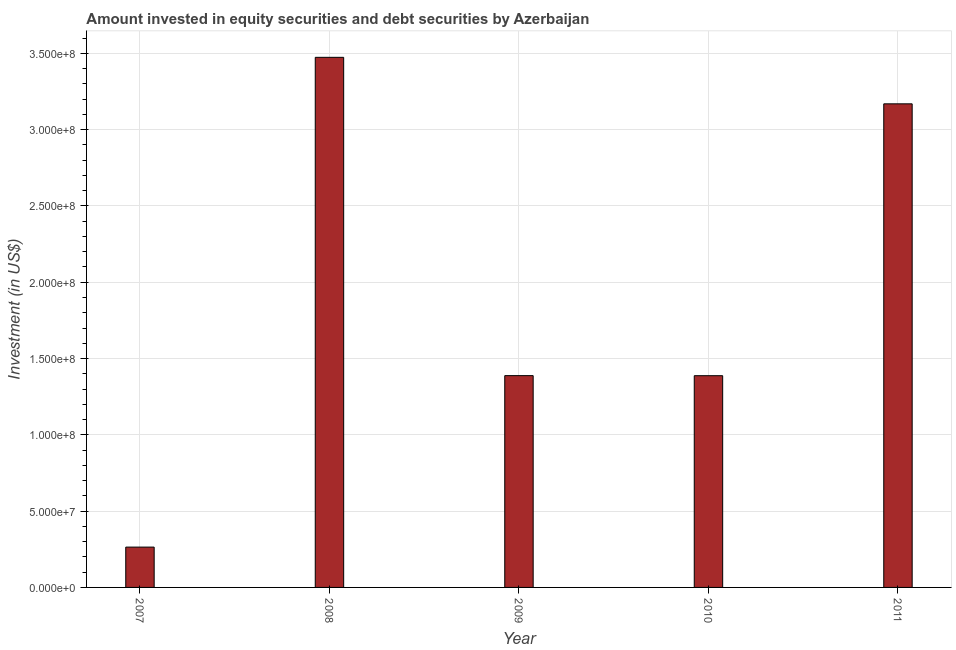What is the title of the graph?
Keep it short and to the point. Amount invested in equity securities and debt securities by Azerbaijan. What is the label or title of the X-axis?
Your answer should be very brief. Year. What is the label or title of the Y-axis?
Provide a short and direct response. Investment (in US$). What is the portfolio investment in 2008?
Offer a terse response. 3.47e+08. Across all years, what is the maximum portfolio investment?
Make the answer very short. 3.47e+08. Across all years, what is the minimum portfolio investment?
Offer a very short reply. 2.64e+07. In which year was the portfolio investment maximum?
Offer a very short reply. 2008. What is the sum of the portfolio investment?
Offer a terse response. 9.68e+08. What is the difference between the portfolio investment in 2009 and 2011?
Offer a very short reply. -1.78e+08. What is the average portfolio investment per year?
Offer a very short reply. 1.94e+08. What is the median portfolio investment?
Give a very brief answer. 1.39e+08. Do a majority of the years between 2010 and 2007 (inclusive) have portfolio investment greater than 320000000 US$?
Provide a short and direct response. Yes. What is the ratio of the portfolio investment in 2008 to that in 2010?
Give a very brief answer. 2.5. Is the difference between the portfolio investment in 2007 and 2008 greater than the difference between any two years?
Offer a terse response. Yes. What is the difference between the highest and the second highest portfolio investment?
Keep it short and to the point. 3.05e+07. Is the sum of the portfolio investment in 2007 and 2008 greater than the maximum portfolio investment across all years?
Offer a terse response. Yes. What is the difference between the highest and the lowest portfolio investment?
Your response must be concise. 3.21e+08. Are all the bars in the graph horizontal?
Your answer should be compact. No. How many years are there in the graph?
Provide a succinct answer. 5. What is the difference between two consecutive major ticks on the Y-axis?
Your answer should be compact. 5.00e+07. Are the values on the major ticks of Y-axis written in scientific E-notation?
Make the answer very short. Yes. What is the Investment (in US$) of 2007?
Ensure brevity in your answer.  2.64e+07. What is the Investment (in US$) in 2008?
Give a very brief answer. 3.47e+08. What is the Investment (in US$) of 2009?
Make the answer very short. 1.39e+08. What is the Investment (in US$) in 2010?
Your answer should be very brief. 1.39e+08. What is the Investment (in US$) of 2011?
Make the answer very short. 3.17e+08. What is the difference between the Investment (in US$) in 2007 and 2008?
Your answer should be compact. -3.21e+08. What is the difference between the Investment (in US$) in 2007 and 2009?
Your answer should be compact. -1.12e+08. What is the difference between the Investment (in US$) in 2007 and 2010?
Give a very brief answer. -1.12e+08. What is the difference between the Investment (in US$) in 2007 and 2011?
Provide a short and direct response. -2.90e+08. What is the difference between the Investment (in US$) in 2008 and 2009?
Provide a short and direct response. 2.09e+08. What is the difference between the Investment (in US$) in 2008 and 2010?
Give a very brief answer. 2.09e+08. What is the difference between the Investment (in US$) in 2008 and 2011?
Provide a short and direct response. 3.05e+07. What is the difference between the Investment (in US$) in 2009 and 2010?
Your answer should be compact. 4.40e+04. What is the difference between the Investment (in US$) in 2009 and 2011?
Provide a succinct answer. -1.78e+08. What is the difference between the Investment (in US$) in 2010 and 2011?
Provide a short and direct response. -1.78e+08. What is the ratio of the Investment (in US$) in 2007 to that in 2008?
Ensure brevity in your answer.  0.08. What is the ratio of the Investment (in US$) in 2007 to that in 2009?
Your answer should be very brief. 0.19. What is the ratio of the Investment (in US$) in 2007 to that in 2010?
Your answer should be very brief. 0.19. What is the ratio of the Investment (in US$) in 2007 to that in 2011?
Keep it short and to the point. 0.08. What is the ratio of the Investment (in US$) in 2008 to that in 2009?
Your answer should be very brief. 2.5. What is the ratio of the Investment (in US$) in 2008 to that in 2010?
Keep it short and to the point. 2.5. What is the ratio of the Investment (in US$) in 2008 to that in 2011?
Give a very brief answer. 1.1. What is the ratio of the Investment (in US$) in 2009 to that in 2011?
Ensure brevity in your answer.  0.44. What is the ratio of the Investment (in US$) in 2010 to that in 2011?
Keep it short and to the point. 0.44. 